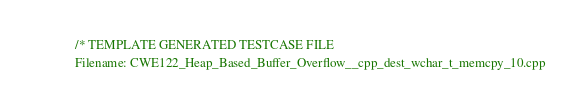Convert code to text. <code><loc_0><loc_0><loc_500><loc_500><_C++_>/* TEMPLATE GENERATED TESTCASE FILE
Filename: CWE122_Heap_Based_Buffer_Overflow__cpp_dest_wchar_t_memcpy_10.cpp</code> 